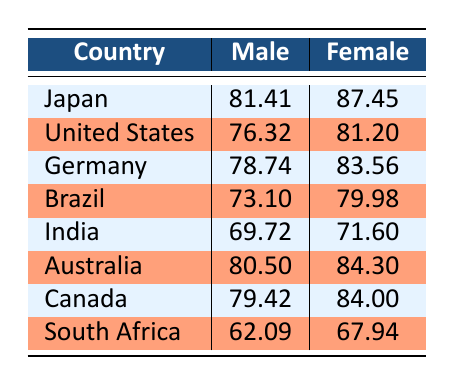What is the life expectancy for females in Japan? From the table, Japan has a female life expectancy of 87.45 years.
Answer: 87.45 What is the life expectancy for males in South Africa? According to the table, the life expectancy for males in South Africa is 62.09 years.
Answer: 62.09 Which country has the highest life expectancy for males? By comparing the male life expectancies listed, Japan has the highest at 81.41 years.
Answer: Japan What is the difference in life expectancy between males and females in Germany? The male life expectancy in Germany is 78.74 years and the female life expectancy is 83.56 years. The difference is 83.56 - 78.74 = 4.82 years.
Answer: 4.82 Is the life expectancy of females greater than that of males in Brazil? In Brazil, the female life expectancy is 79.98 years and the male life expectancy is 73.10 years, so females have a greater life expectancy.
Answer: Yes What is the average life expectancy for males across all countries listed? The male life expectancies are 81.41, 76.32, 78.74, 73.10, 69.72, 80.50, 79.42, and 62.09 years. Summing these gives a total of 501.78 years, and dividing by 8 gives an average of 62.72 years.
Answer: 62.72 Which country has a life expectancy for females less than 72 years? Looking at the table, India has a female life expectancy of 71.60 years, which is less than 72.
Answer: India What is the combined life expectancy for males and females in Canada? The male life expectancy in Canada is 79.42 years and the female life expectancy is 84.00 years. Their combined value is 79.42 + 84.00 = 163.42 years.
Answer: 163.42 Which country has the lowest life expectancy for females? By reviewing the female life expectancies, South Africa has the lowest at 67.94 years.
Answer: South Africa 